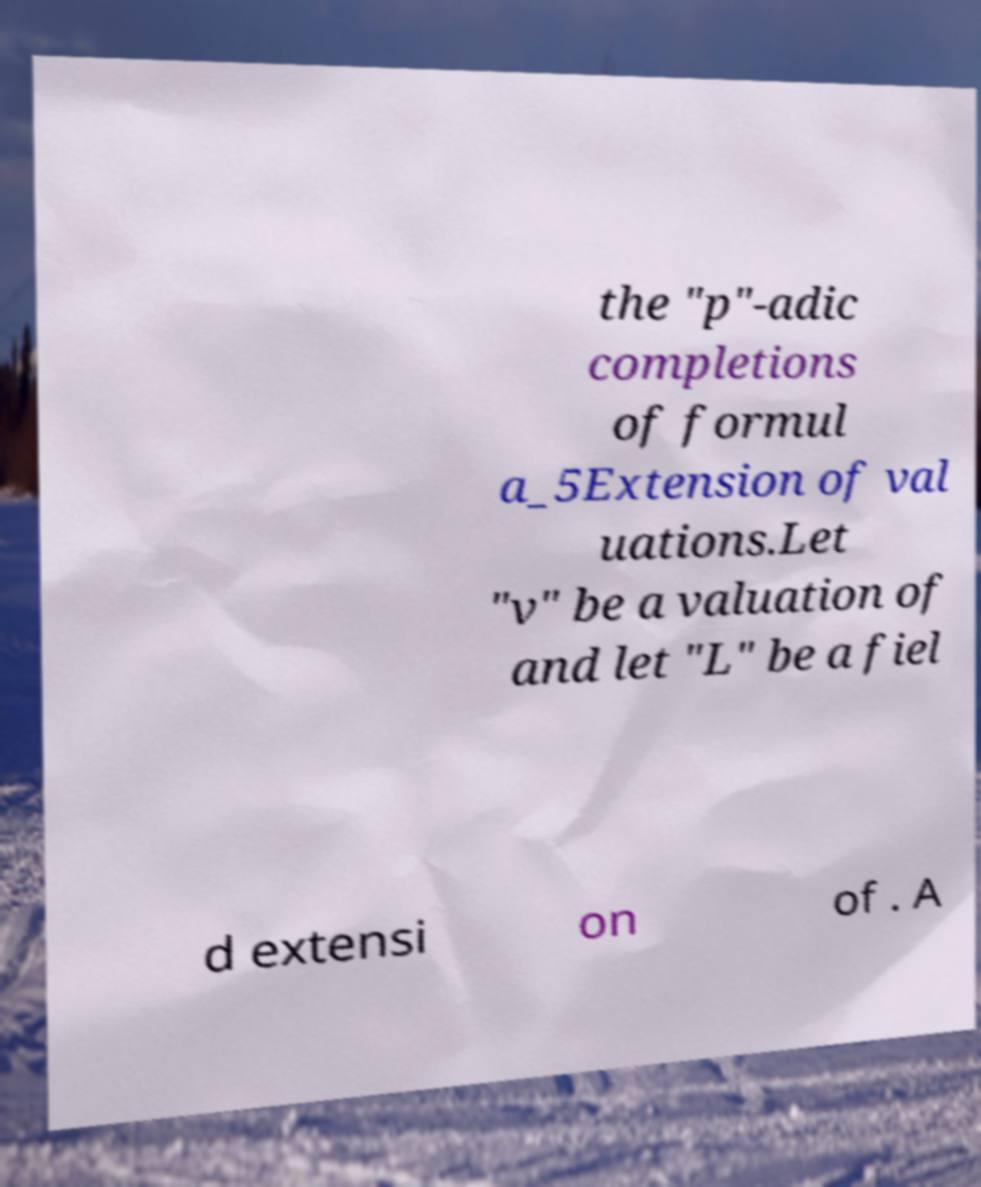There's text embedded in this image that I need extracted. Can you transcribe it verbatim? the "p"-adic completions of formul a_5Extension of val uations.Let "v" be a valuation of and let "L" be a fiel d extensi on of . A 